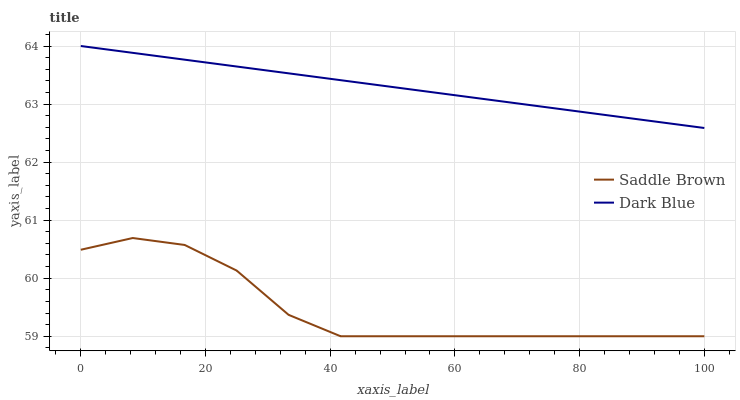Does Saddle Brown have the maximum area under the curve?
Answer yes or no. No. Is Saddle Brown the smoothest?
Answer yes or no. No. Does Saddle Brown have the highest value?
Answer yes or no. No. Is Saddle Brown less than Dark Blue?
Answer yes or no. Yes. Is Dark Blue greater than Saddle Brown?
Answer yes or no. Yes. Does Saddle Brown intersect Dark Blue?
Answer yes or no. No. 